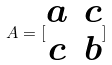Convert formula to latex. <formula><loc_0><loc_0><loc_500><loc_500>A = [ \begin{matrix} a & c \\ c & b \end{matrix} ]</formula> 